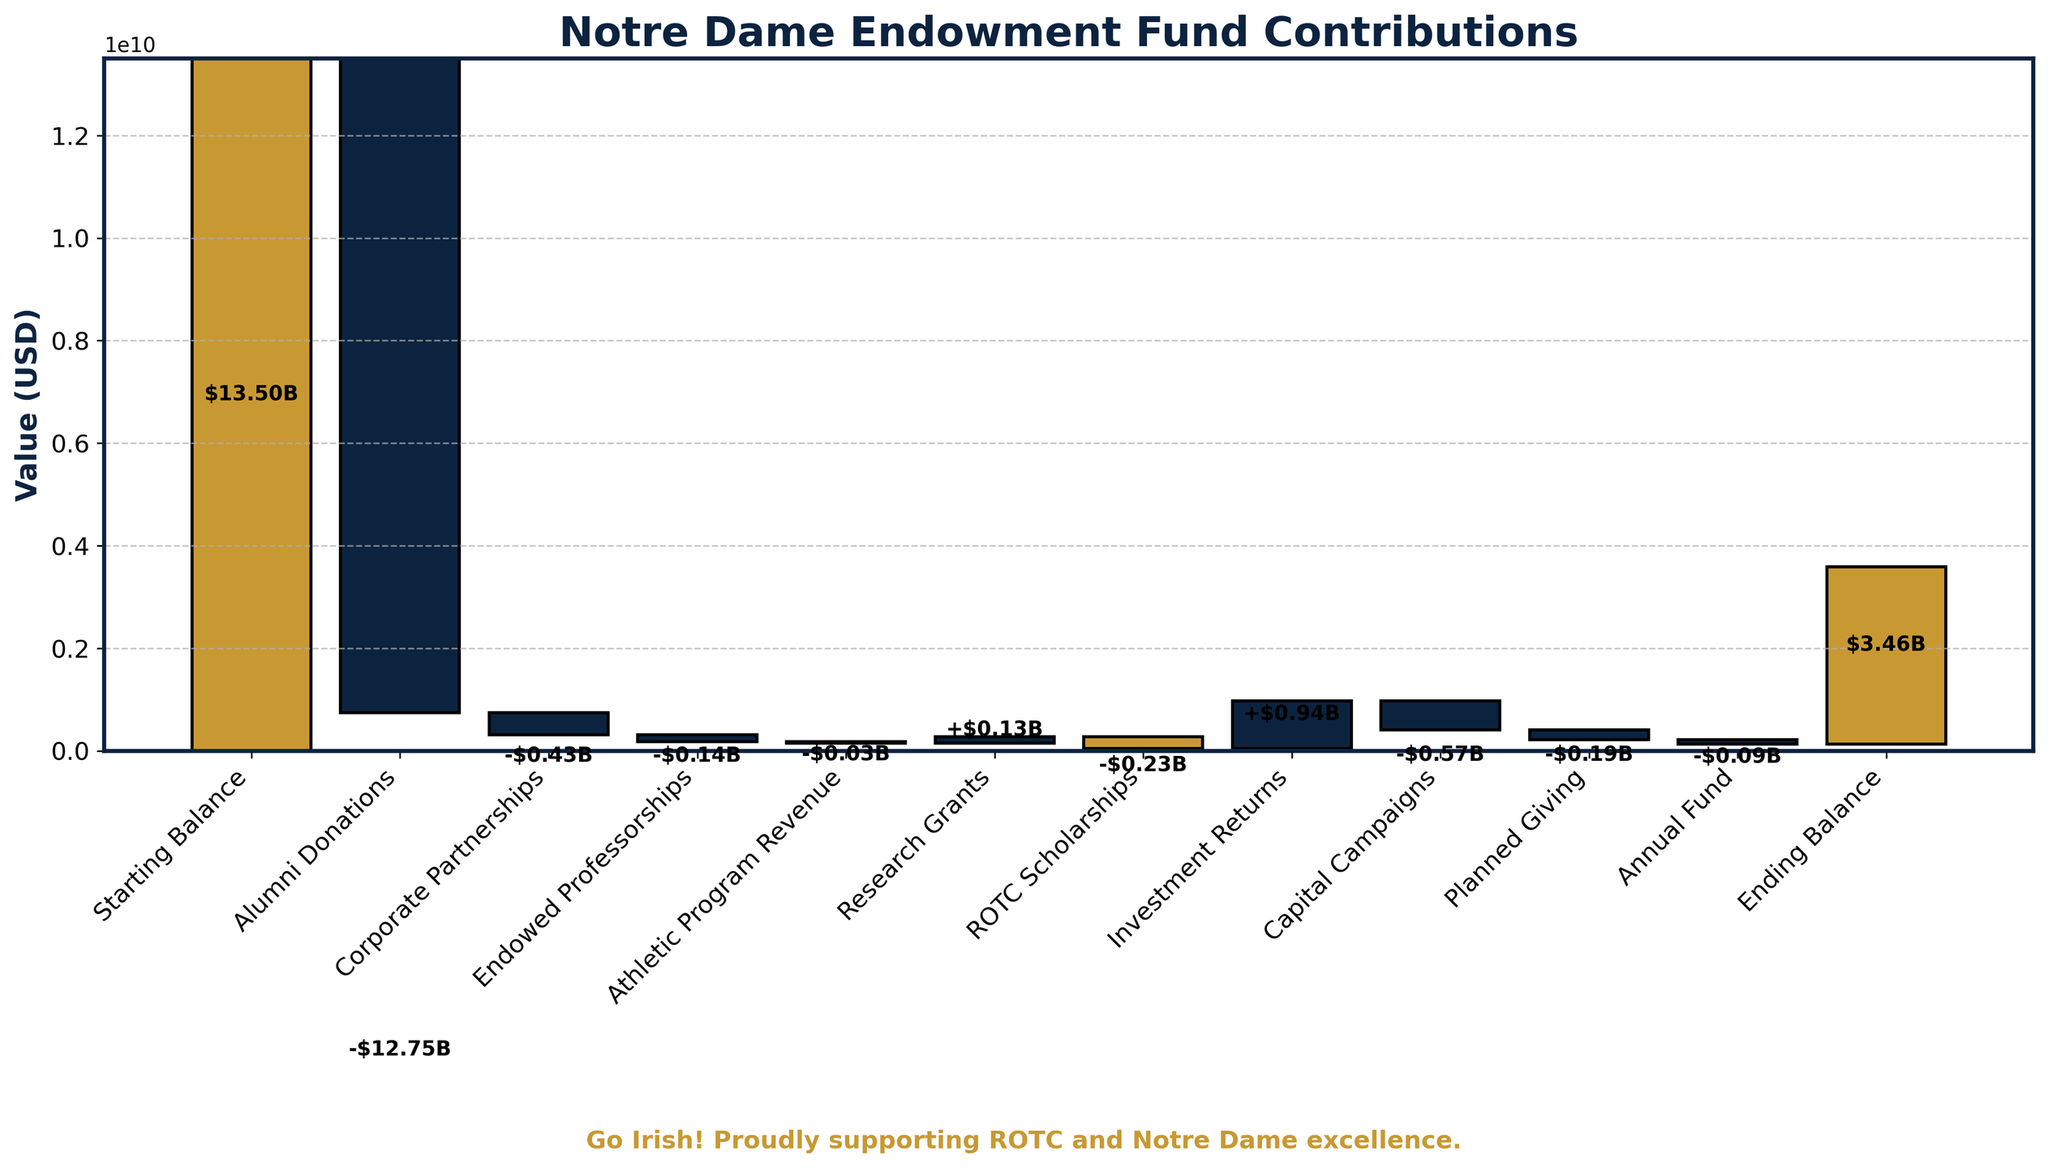What is the title of the chart? The chart title is displayed prominently on top, indicating the focus of the visual information.
Answer: Notre Dame Endowment Fund Contributions What is the starting balance shown in the chart? The starting balance is the first value on the chart, typically at the bottom or leftmost position.
Answer: $13.50B Which category has the smallest contribution? By comparing the heights of all the bars for each category, the smallest contribution can be identified.
Answer: ROTC Scholarships How much did the alumni donate to the endowment fund? The detail on alumni donations is represented by a specific bar, whose value can be extracted.
Answer: $0.75B How much money was generated from research grants? The research grants contribution is represented by a specific bar in the chart, identifiable by its label.
Answer: $0.28B What is the ending balance of the endowment fund according to the chart? The ending balance is shown as the last value or bar on the chart, typically at the top or rightmost position.
Answer: $16.97B How much more was generated from investment returns compared to ROTC scholarships? Subtract the value of ROTC scholarships from investment returns to find the difference.
Answer: $0.935B Which category contributed more, athletic program revenue or endowed professorships? Compare the heights or values of the bars corresponding to athletic program revenue and endowed professorships.
Answer: Endowed Professorships What is the total contribution from corporate partnerships and planned giving combined? Sum the values of corporate partnerships and planned giving contributions.
Answer: $0.54B Which category contributed the most to the endowment fund? Identifying the tallest bar or the highest value among the categories shows the largest contribution.
Answer: Investment Returns 